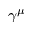Convert formula to latex. <formula><loc_0><loc_0><loc_500><loc_500>\gamma ^ { \mu }</formula> 